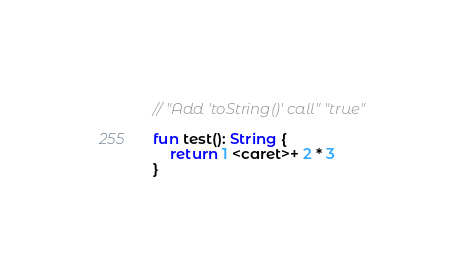Convert code to text. <code><loc_0><loc_0><loc_500><loc_500><_Kotlin_>// "Add 'toString()' call" "true"

fun test(): String {
    return 1 <caret>+ 2 * 3
}</code> 